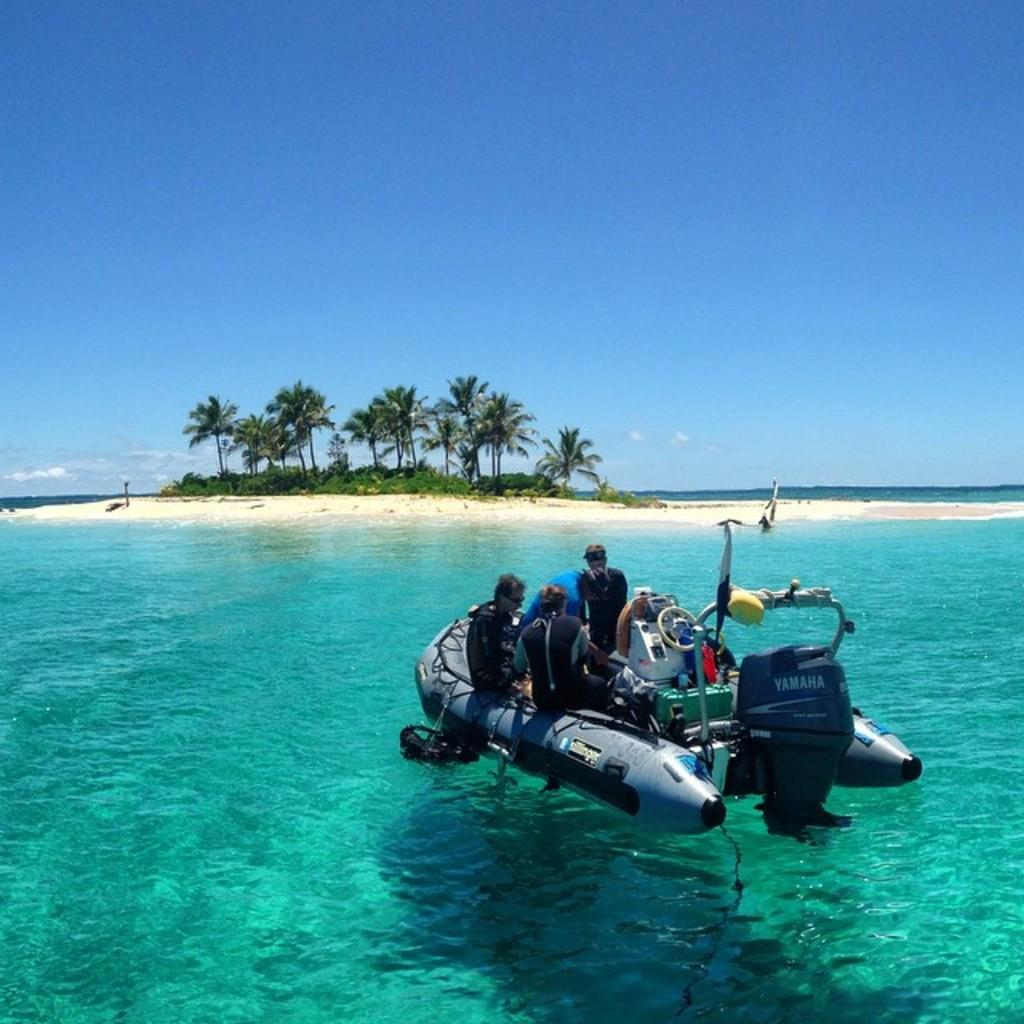What are the persons in the image doing? The persons in the image are sitting on an inflatable boat. What is the condition of the boat in the image? The inflatable boat is floating on the water. What type of terrain can be seen in the background of the image? There is sand visible in the background. What else is visible in the background of the image? There are trees and the sky with clouds in the background. What type of square object can be seen in the hands of the persons on the boat? There is no square object visible in the hands of the persons on the boat in the image. 